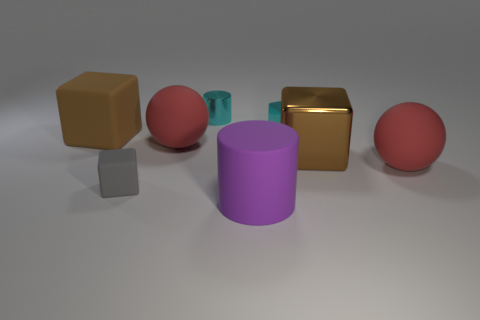Add 1 tiny cyan metal blocks. How many objects exist? 9 Subtract all cyan blocks. How many blocks are left? 3 Subtract all cylinders. How many objects are left? 6 Subtract 1 spheres. How many spheres are left? 1 Subtract all tiny blue blocks. Subtract all small gray cubes. How many objects are left? 7 Add 1 big red things. How many big red things are left? 3 Add 7 matte cylinders. How many matte cylinders exist? 8 Subtract 1 cyan cylinders. How many objects are left? 7 Subtract all cyan cylinders. Subtract all blue cubes. How many cylinders are left? 1 Subtract all gray cylinders. How many gray cubes are left? 1 